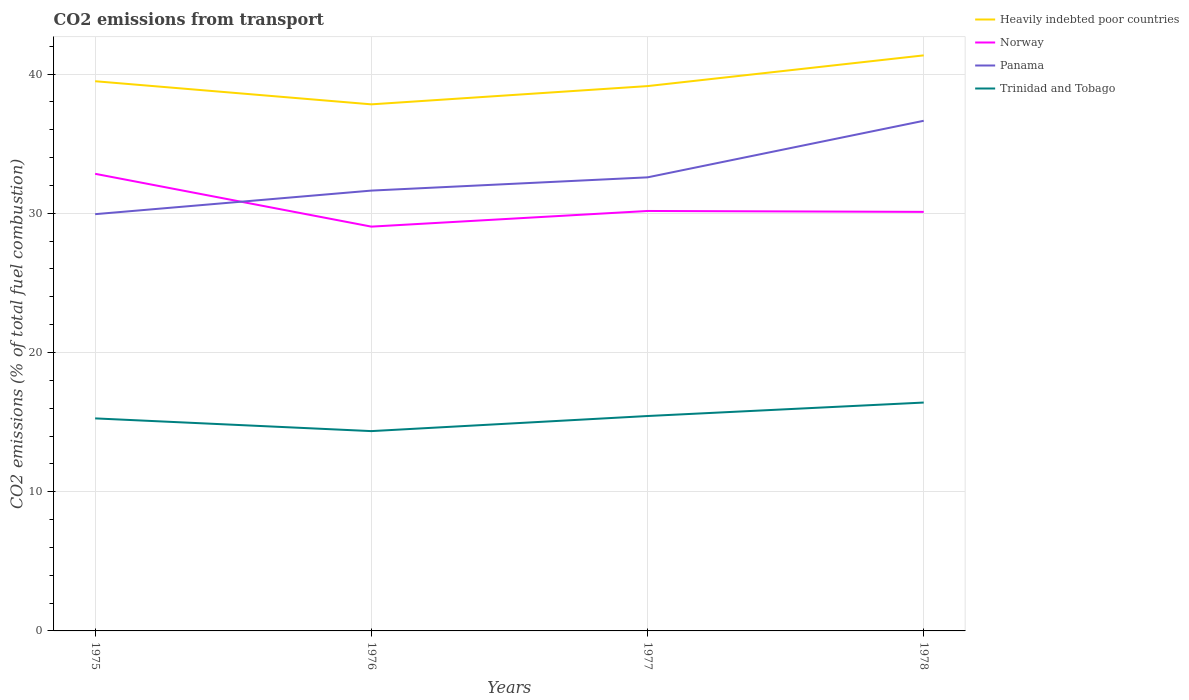Does the line corresponding to Heavily indebted poor countries intersect with the line corresponding to Norway?
Make the answer very short. No. Is the number of lines equal to the number of legend labels?
Your answer should be compact. Yes. Across all years, what is the maximum total CO2 emitted in Heavily indebted poor countries?
Provide a short and direct response. 37.82. In which year was the total CO2 emitted in Trinidad and Tobago maximum?
Offer a very short reply. 1976. What is the total total CO2 emitted in Norway in the graph?
Provide a succinct answer. -1.06. What is the difference between the highest and the second highest total CO2 emitted in Heavily indebted poor countries?
Your response must be concise. 3.52. What is the difference between the highest and the lowest total CO2 emitted in Heavily indebted poor countries?
Make the answer very short. 2. How many years are there in the graph?
Ensure brevity in your answer.  4. Does the graph contain grids?
Your response must be concise. Yes. How many legend labels are there?
Offer a terse response. 4. How are the legend labels stacked?
Make the answer very short. Vertical. What is the title of the graph?
Provide a succinct answer. CO2 emissions from transport. Does "Zambia" appear as one of the legend labels in the graph?
Your answer should be compact. No. What is the label or title of the X-axis?
Offer a terse response. Years. What is the label or title of the Y-axis?
Your answer should be very brief. CO2 emissions (% of total fuel combustion). What is the CO2 emissions (% of total fuel combustion) of Heavily indebted poor countries in 1975?
Your answer should be very brief. 39.49. What is the CO2 emissions (% of total fuel combustion) of Norway in 1975?
Your answer should be compact. 32.84. What is the CO2 emissions (% of total fuel combustion) in Panama in 1975?
Your response must be concise. 29.94. What is the CO2 emissions (% of total fuel combustion) of Trinidad and Tobago in 1975?
Your answer should be compact. 15.27. What is the CO2 emissions (% of total fuel combustion) in Heavily indebted poor countries in 1976?
Offer a terse response. 37.82. What is the CO2 emissions (% of total fuel combustion) in Norway in 1976?
Make the answer very short. 29.04. What is the CO2 emissions (% of total fuel combustion) in Panama in 1976?
Provide a succinct answer. 31.63. What is the CO2 emissions (% of total fuel combustion) in Trinidad and Tobago in 1976?
Offer a terse response. 14.35. What is the CO2 emissions (% of total fuel combustion) in Heavily indebted poor countries in 1977?
Keep it short and to the point. 39.14. What is the CO2 emissions (% of total fuel combustion) in Norway in 1977?
Keep it short and to the point. 30.17. What is the CO2 emissions (% of total fuel combustion) in Panama in 1977?
Give a very brief answer. 32.58. What is the CO2 emissions (% of total fuel combustion) in Trinidad and Tobago in 1977?
Offer a terse response. 15.44. What is the CO2 emissions (% of total fuel combustion) in Heavily indebted poor countries in 1978?
Make the answer very short. 41.34. What is the CO2 emissions (% of total fuel combustion) in Norway in 1978?
Make the answer very short. 30.1. What is the CO2 emissions (% of total fuel combustion) of Panama in 1978?
Offer a terse response. 36.64. What is the CO2 emissions (% of total fuel combustion) in Trinidad and Tobago in 1978?
Make the answer very short. 16.4. Across all years, what is the maximum CO2 emissions (% of total fuel combustion) of Heavily indebted poor countries?
Give a very brief answer. 41.34. Across all years, what is the maximum CO2 emissions (% of total fuel combustion) in Norway?
Provide a succinct answer. 32.84. Across all years, what is the maximum CO2 emissions (% of total fuel combustion) in Panama?
Offer a terse response. 36.64. Across all years, what is the maximum CO2 emissions (% of total fuel combustion) of Trinidad and Tobago?
Offer a terse response. 16.4. Across all years, what is the minimum CO2 emissions (% of total fuel combustion) of Heavily indebted poor countries?
Your answer should be very brief. 37.82. Across all years, what is the minimum CO2 emissions (% of total fuel combustion) of Norway?
Give a very brief answer. 29.04. Across all years, what is the minimum CO2 emissions (% of total fuel combustion) in Panama?
Give a very brief answer. 29.94. Across all years, what is the minimum CO2 emissions (% of total fuel combustion) in Trinidad and Tobago?
Your response must be concise. 14.35. What is the total CO2 emissions (% of total fuel combustion) in Heavily indebted poor countries in the graph?
Provide a succinct answer. 157.79. What is the total CO2 emissions (% of total fuel combustion) of Norway in the graph?
Give a very brief answer. 122.14. What is the total CO2 emissions (% of total fuel combustion) in Panama in the graph?
Provide a succinct answer. 130.79. What is the total CO2 emissions (% of total fuel combustion) in Trinidad and Tobago in the graph?
Offer a very short reply. 61.46. What is the difference between the CO2 emissions (% of total fuel combustion) of Heavily indebted poor countries in 1975 and that in 1976?
Your answer should be very brief. 1.66. What is the difference between the CO2 emissions (% of total fuel combustion) in Norway in 1975 and that in 1976?
Make the answer very short. 3.79. What is the difference between the CO2 emissions (% of total fuel combustion) in Panama in 1975 and that in 1976?
Offer a terse response. -1.69. What is the difference between the CO2 emissions (% of total fuel combustion) of Trinidad and Tobago in 1975 and that in 1976?
Your response must be concise. 0.91. What is the difference between the CO2 emissions (% of total fuel combustion) in Heavily indebted poor countries in 1975 and that in 1977?
Your response must be concise. 0.35. What is the difference between the CO2 emissions (% of total fuel combustion) of Norway in 1975 and that in 1977?
Offer a terse response. 2.67. What is the difference between the CO2 emissions (% of total fuel combustion) of Panama in 1975 and that in 1977?
Give a very brief answer. -2.64. What is the difference between the CO2 emissions (% of total fuel combustion) in Trinidad and Tobago in 1975 and that in 1977?
Your response must be concise. -0.17. What is the difference between the CO2 emissions (% of total fuel combustion) in Heavily indebted poor countries in 1975 and that in 1978?
Provide a succinct answer. -1.86. What is the difference between the CO2 emissions (% of total fuel combustion) of Norway in 1975 and that in 1978?
Offer a very short reply. 2.73. What is the difference between the CO2 emissions (% of total fuel combustion) of Panama in 1975 and that in 1978?
Offer a terse response. -6.71. What is the difference between the CO2 emissions (% of total fuel combustion) of Trinidad and Tobago in 1975 and that in 1978?
Ensure brevity in your answer.  -1.14. What is the difference between the CO2 emissions (% of total fuel combustion) of Heavily indebted poor countries in 1976 and that in 1977?
Offer a terse response. -1.31. What is the difference between the CO2 emissions (% of total fuel combustion) of Norway in 1976 and that in 1977?
Offer a very short reply. -1.12. What is the difference between the CO2 emissions (% of total fuel combustion) in Panama in 1976 and that in 1977?
Ensure brevity in your answer.  -0.95. What is the difference between the CO2 emissions (% of total fuel combustion) in Trinidad and Tobago in 1976 and that in 1977?
Give a very brief answer. -1.08. What is the difference between the CO2 emissions (% of total fuel combustion) in Heavily indebted poor countries in 1976 and that in 1978?
Your answer should be compact. -3.52. What is the difference between the CO2 emissions (% of total fuel combustion) of Norway in 1976 and that in 1978?
Your answer should be very brief. -1.06. What is the difference between the CO2 emissions (% of total fuel combustion) of Panama in 1976 and that in 1978?
Ensure brevity in your answer.  -5.01. What is the difference between the CO2 emissions (% of total fuel combustion) of Trinidad and Tobago in 1976 and that in 1978?
Give a very brief answer. -2.05. What is the difference between the CO2 emissions (% of total fuel combustion) in Heavily indebted poor countries in 1977 and that in 1978?
Provide a succinct answer. -2.21. What is the difference between the CO2 emissions (% of total fuel combustion) in Norway in 1977 and that in 1978?
Provide a succinct answer. 0.07. What is the difference between the CO2 emissions (% of total fuel combustion) of Panama in 1977 and that in 1978?
Your answer should be compact. -4.06. What is the difference between the CO2 emissions (% of total fuel combustion) of Trinidad and Tobago in 1977 and that in 1978?
Offer a terse response. -0.97. What is the difference between the CO2 emissions (% of total fuel combustion) of Heavily indebted poor countries in 1975 and the CO2 emissions (% of total fuel combustion) of Norway in 1976?
Offer a very short reply. 10.44. What is the difference between the CO2 emissions (% of total fuel combustion) in Heavily indebted poor countries in 1975 and the CO2 emissions (% of total fuel combustion) in Panama in 1976?
Provide a succinct answer. 7.86. What is the difference between the CO2 emissions (% of total fuel combustion) of Heavily indebted poor countries in 1975 and the CO2 emissions (% of total fuel combustion) of Trinidad and Tobago in 1976?
Your answer should be very brief. 25.13. What is the difference between the CO2 emissions (% of total fuel combustion) in Norway in 1975 and the CO2 emissions (% of total fuel combustion) in Panama in 1976?
Keep it short and to the point. 1.21. What is the difference between the CO2 emissions (% of total fuel combustion) of Norway in 1975 and the CO2 emissions (% of total fuel combustion) of Trinidad and Tobago in 1976?
Give a very brief answer. 18.48. What is the difference between the CO2 emissions (% of total fuel combustion) of Panama in 1975 and the CO2 emissions (% of total fuel combustion) of Trinidad and Tobago in 1976?
Make the answer very short. 15.58. What is the difference between the CO2 emissions (% of total fuel combustion) in Heavily indebted poor countries in 1975 and the CO2 emissions (% of total fuel combustion) in Norway in 1977?
Your answer should be very brief. 9.32. What is the difference between the CO2 emissions (% of total fuel combustion) of Heavily indebted poor countries in 1975 and the CO2 emissions (% of total fuel combustion) of Panama in 1977?
Ensure brevity in your answer.  6.9. What is the difference between the CO2 emissions (% of total fuel combustion) in Heavily indebted poor countries in 1975 and the CO2 emissions (% of total fuel combustion) in Trinidad and Tobago in 1977?
Make the answer very short. 24.05. What is the difference between the CO2 emissions (% of total fuel combustion) of Norway in 1975 and the CO2 emissions (% of total fuel combustion) of Panama in 1977?
Ensure brevity in your answer.  0.25. What is the difference between the CO2 emissions (% of total fuel combustion) of Norway in 1975 and the CO2 emissions (% of total fuel combustion) of Trinidad and Tobago in 1977?
Ensure brevity in your answer.  17.4. What is the difference between the CO2 emissions (% of total fuel combustion) in Panama in 1975 and the CO2 emissions (% of total fuel combustion) in Trinidad and Tobago in 1977?
Make the answer very short. 14.5. What is the difference between the CO2 emissions (% of total fuel combustion) of Heavily indebted poor countries in 1975 and the CO2 emissions (% of total fuel combustion) of Norway in 1978?
Ensure brevity in your answer.  9.38. What is the difference between the CO2 emissions (% of total fuel combustion) of Heavily indebted poor countries in 1975 and the CO2 emissions (% of total fuel combustion) of Panama in 1978?
Provide a succinct answer. 2.84. What is the difference between the CO2 emissions (% of total fuel combustion) of Heavily indebted poor countries in 1975 and the CO2 emissions (% of total fuel combustion) of Trinidad and Tobago in 1978?
Make the answer very short. 23.08. What is the difference between the CO2 emissions (% of total fuel combustion) in Norway in 1975 and the CO2 emissions (% of total fuel combustion) in Panama in 1978?
Provide a succinct answer. -3.81. What is the difference between the CO2 emissions (% of total fuel combustion) in Norway in 1975 and the CO2 emissions (% of total fuel combustion) in Trinidad and Tobago in 1978?
Provide a short and direct response. 16.43. What is the difference between the CO2 emissions (% of total fuel combustion) in Panama in 1975 and the CO2 emissions (% of total fuel combustion) in Trinidad and Tobago in 1978?
Make the answer very short. 13.53. What is the difference between the CO2 emissions (% of total fuel combustion) of Heavily indebted poor countries in 1976 and the CO2 emissions (% of total fuel combustion) of Norway in 1977?
Ensure brevity in your answer.  7.66. What is the difference between the CO2 emissions (% of total fuel combustion) in Heavily indebted poor countries in 1976 and the CO2 emissions (% of total fuel combustion) in Panama in 1977?
Ensure brevity in your answer.  5.24. What is the difference between the CO2 emissions (% of total fuel combustion) of Heavily indebted poor countries in 1976 and the CO2 emissions (% of total fuel combustion) of Trinidad and Tobago in 1977?
Your response must be concise. 22.39. What is the difference between the CO2 emissions (% of total fuel combustion) in Norway in 1976 and the CO2 emissions (% of total fuel combustion) in Panama in 1977?
Provide a short and direct response. -3.54. What is the difference between the CO2 emissions (% of total fuel combustion) in Norway in 1976 and the CO2 emissions (% of total fuel combustion) in Trinidad and Tobago in 1977?
Ensure brevity in your answer.  13.6. What is the difference between the CO2 emissions (% of total fuel combustion) in Panama in 1976 and the CO2 emissions (% of total fuel combustion) in Trinidad and Tobago in 1977?
Your answer should be very brief. 16.19. What is the difference between the CO2 emissions (% of total fuel combustion) of Heavily indebted poor countries in 1976 and the CO2 emissions (% of total fuel combustion) of Norway in 1978?
Your response must be concise. 7.72. What is the difference between the CO2 emissions (% of total fuel combustion) in Heavily indebted poor countries in 1976 and the CO2 emissions (% of total fuel combustion) in Panama in 1978?
Provide a short and direct response. 1.18. What is the difference between the CO2 emissions (% of total fuel combustion) in Heavily indebted poor countries in 1976 and the CO2 emissions (% of total fuel combustion) in Trinidad and Tobago in 1978?
Give a very brief answer. 21.42. What is the difference between the CO2 emissions (% of total fuel combustion) in Norway in 1976 and the CO2 emissions (% of total fuel combustion) in Panama in 1978?
Your answer should be very brief. -7.6. What is the difference between the CO2 emissions (% of total fuel combustion) in Norway in 1976 and the CO2 emissions (% of total fuel combustion) in Trinidad and Tobago in 1978?
Make the answer very short. 12.64. What is the difference between the CO2 emissions (% of total fuel combustion) of Panama in 1976 and the CO2 emissions (% of total fuel combustion) of Trinidad and Tobago in 1978?
Your response must be concise. 15.23. What is the difference between the CO2 emissions (% of total fuel combustion) of Heavily indebted poor countries in 1977 and the CO2 emissions (% of total fuel combustion) of Norway in 1978?
Make the answer very short. 9.04. What is the difference between the CO2 emissions (% of total fuel combustion) in Heavily indebted poor countries in 1977 and the CO2 emissions (% of total fuel combustion) in Panama in 1978?
Ensure brevity in your answer.  2.49. What is the difference between the CO2 emissions (% of total fuel combustion) in Heavily indebted poor countries in 1977 and the CO2 emissions (% of total fuel combustion) in Trinidad and Tobago in 1978?
Your response must be concise. 22.73. What is the difference between the CO2 emissions (% of total fuel combustion) in Norway in 1977 and the CO2 emissions (% of total fuel combustion) in Panama in 1978?
Ensure brevity in your answer.  -6.48. What is the difference between the CO2 emissions (% of total fuel combustion) of Norway in 1977 and the CO2 emissions (% of total fuel combustion) of Trinidad and Tobago in 1978?
Offer a terse response. 13.76. What is the difference between the CO2 emissions (% of total fuel combustion) in Panama in 1977 and the CO2 emissions (% of total fuel combustion) in Trinidad and Tobago in 1978?
Ensure brevity in your answer.  16.18. What is the average CO2 emissions (% of total fuel combustion) of Heavily indebted poor countries per year?
Offer a terse response. 39.45. What is the average CO2 emissions (% of total fuel combustion) of Norway per year?
Your response must be concise. 30.54. What is the average CO2 emissions (% of total fuel combustion) in Panama per year?
Keep it short and to the point. 32.7. What is the average CO2 emissions (% of total fuel combustion) in Trinidad and Tobago per year?
Offer a very short reply. 15.36. In the year 1975, what is the difference between the CO2 emissions (% of total fuel combustion) in Heavily indebted poor countries and CO2 emissions (% of total fuel combustion) in Norway?
Keep it short and to the point. 6.65. In the year 1975, what is the difference between the CO2 emissions (% of total fuel combustion) in Heavily indebted poor countries and CO2 emissions (% of total fuel combustion) in Panama?
Keep it short and to the point. 9.55. In the year 1975, what is the difference between the CO2 emissions (% of total fuel combustion) in Heavily indebted poor countries and CO2 emissions (% of total fuel combustion) in Trinidad and Tobago?
Keep it short and to the point. 24.22. In the year 1975, what is the difference between the CO2 emissions (% of total fuel combustion) of Norway and CO2 emissions (% of total fuel combustion) of Panama?
Your answer should be compact. 2.9. In the year 1975, what is the difference between the CO2 emissions (% of total fuel combustion) of Norway and CO2 emissions (% of total fuel combustion) of Trinidad and Tobago?
Keep it short and to the point. 17.57. In the year 1975, what is the difference between the CO2 emissions (% of total fuel combustion) in Panama and CO2 emissions (% of total fuel combustion) in Trinidad and Tobago?
Keep it short and to the point. 14.67. In the year 1976, what is the difference between the CO2 emissions (% of total fuel combustion) of Heavily indebted poor countries and CO2 emissions (% of total fuel combustion) of Norway?
Provide a short and direct response. 8.78. In the year 1976, what is the difference between the CO2 emissions (% of total fuel combustion) in Heavily indebted poor countries and CO2 emissions (% of total fuel combustion) in Panama?
Ensure brevity in your answer.  6.2. In the year 1976, what is the difference between the CO2 emissions (% of total fuel combustion) of Heavily indebted poor countries and CO2 emissions (% of total fuel combustion) of Trinidad and Tobago?
Your answer should be very brief. 23.47. In the year 1976, what is the difference between the CO2 emissions (% of total fuel combustion) of Norway and CO2 emissions (% of total fuel combustion) of Panama?
Offer a very short reply. -2.59. In the year 1976, what is the difference between the CO2 emissions (% of total fuel combustion) of Norway and CO2 emissions (% of total fuel combustion) of Trinidad and Tobago?
Provide a succinct answer. 14.69. In the year 1976, what is the difference between the CO2 emissions (% of total fuel combustion) of Panama and CO2 emissions (% of total fuel combustion) of Trinidad and Tobago?
Your answer should be compact. 17.28. In the year 1977, what is the difference between the CO2 emissions (% of total fuel combustion) of Heavily indebted poor countries and CO2 emissions (% of total fuel combustion) of Norway?
Your response must be concise. 8.97. In the year 1977, what is the difference between the CO2 emissions (% of total fuel combustion) in Heavily indebted poor countries and CO2 emissions (% of total fuel combustion) in Panama?
Give a very brief answer. 6.55. In the year 1977, what is the difference between the CO2 emissions (% of total fuel combustion) in Heavily indebted poor countries and CO2 emissions (% of total fuel combustion) in Trinidad and Tobago?
Keep it short and to the point. 23.7. In the year 1977, what is the difference between the CO2 emissions (% of total fuel combustion) in Norway and CO2 emissions (% of total fuel combustion) in Panama?
Provide a succinct answer. -2.41. In the year 1977, what is the difference between the CO2 emissions (% of total fuel combustion) of Norway and CO2 emissions (% of total fuel combustion) of Trinidad and Tobago?
Offer a very short reply. 14.73. In the year 1977, what is the difference between the CO2 emissions (% of total fuel combustion) in Panama and CO2 emissions (% of total fuel combustion) in Trinidad and Tobago?
Offer a very short reply. 17.14. In the year 1978, what is the difference between the CO2 emissions (% of total fuel combustion) of Heavily indebted poor countries and CO2 emissions (% of total fuel combustion) of Norway?
Ensure brevity in your answer.  11.24. In the year 1978, what is the difference between the CO2 emissions (% of total fuel combustion) in Heavily indebted poor countries and CO2 emissions (% of total fuel combustion) in Panama?
Your answer should be very brief. 4.7. In the year 1978, what is the difference between the CO2 emissions (% of total fuel combustion) in Heavily indebted poor countries and CO2 emissions (% of total fuel combustion) in Trinidad and Tobago?
Offer a very short reply. 24.94. In the year 1978, what is the difference between the CO2 emissions (% of total fuel combustion) in Norway and CO2 emissions (% of total fuel combustion) in Panama?
Give a very brief answer. -6.54. In the year 1978, what is the difference between the CO2 emissions (% of total fuel combustion) in Norway and CO2 emissions (% of total fuel combustion) in Trinidad and Tobago?
Your answer should be compact. 13.7. In the year 1978, what is the difference between the CO2 emissions (% of total fuel combustion) in Panama and CO2 emissions (% of total fuel combustion) in Trinidad and Tobago?
Keep it short and to the point. 20.24. What is the ratio of the CO2 emissions (% of total fuel combustion) in Heavily indebted poor countries in 1975 to that in 1976?
Your answer should be compact. 1.04. What is the ratio of the CO2 emissions (% of total fuel combustion) of Norway in 1975 to that in 1976?
Provide a succinct answer. 1.13. What is the ratio of the CO2 emissions (% of total fuel combustion) of Panama in 1975 to that in 1976?
Give a very brief answer. 0.95. What is the ratio of the CO2 emissions (% of total fuel combustion) of Trinidad and Tobago in 1975 to that in 1976?
Your answer should be very brief. 1.06. What is the ratio of the CO2 emissions (% of total fuel combustion) in Heavily indebted poor countries in 1975 to that in 1977?
Ensure brevity in your answer.  1.01. What is the ratio of the CO2 emissions (% of total fuel combustion) in Norway in 1975 to that in 1977?
Provide a short and direct response. 1.09. What is the ratio of the CO2 emissions (% of total fuel combustion) of Panama in 1975 to that in 1977?
Keep it short and to the point. 0.92. What is the ratio of the CO2 emissions (% of total fuel combustion) of Trinidad and Tobago in 1975 to that in 1977?
Offer a very short reply. 0.99. What is the ratio of the CO2 emissions (% of total fuel combustion) of Heavily indebted poor countries in 1975 to that in 1978?
Give a very brief answer. 0.96. What is the ratio of the CO2 emissions (% of total fuel combustion) of Norway in 1975 to that in 1978?
Give a very brief answer. 1.09. What is the ratio of the CO2 emissions (% of total fuel combustion) of Panama in 1975 to that in 1978?
Offer a very short reply. 0.82. What is the ratio of the CO2 emissions (% of total fuel combustion) in Trinidad and Tobago in 1975 to that in 1978?
Offer a terse response. 0.93. What is the ratio of the CO2 emissions (% of total fuel combustion) in Heavily indebted poor countries in 1976 to that in 1977?
Your response must be concise. 0.97. What is the ratio of the CO2 emissions (% of total fuel combustion) in Norway in 1976 to that in 1977?
Ensure brevity in your answer.  0.96. What is the ratio of the CO2 emissions (% of total fuel combustion) of Panama in 1976 to that in 1977?
Make the answer very short. 0.97. What is the ratio of the CO2 emissions (% of total fuel combustion) of Trinidad and Tobago in 1976 to that in 1977?
Make the answer very short. 0.93. What is the ratio of the CO2 emissions (% of total fuel combustion) in Heavily indebted poor countries in 1976 to that in 1978?
Offer a terse response. 0.91. What is the ratio of the CO2 emissions (% of total fuel combustion) of Norway in 1976 to that in 1978?
Keep it short and to the point. 0.96. What is the ratio of the CO2 emissions (% of total fuel combustion) of Panama in 1976 to that in 1978?
Ensure brevity in your answer.  0.86. What is the ratio of the CO2 emissions (% of total fuel combustion) in Trinidad and Tobago in 1976 to that in 1978?
Keep it short and to the point. 0.87. What is the ratio of the CO2 emissions (% of total fuel combustion) in Heavily indebted poor countries in 1977 to that in 1978?
Your answer should be very brief. 0.95. What is the ratio of the CO2 emissions (% of total fuel combustion) in Panama in 1977 to that in 1978?
Provide a succinct answer. 0.89. What is the ratio of the CO2 emissions (% of total fuel combustion) of Trinidad and Tobago in 1977 to that in 1978?
Offer a very short reply. 0.94. What is the difference between the highest and the second highest CO2 emissions (% of total fuel combustion) of Heavily indebted poor countries?
Your answer should be compact. 1.86. What is the difference between the highest and the second highest CO2 emissions (% of total fuel combustion) in Norway?
Make the answer very short. 2.67. What is the difference between the highest and the second highest CO2 emissions (% of total fuel combustion) of Panama?
Your response must be concise. 4.06. What is the difference between the highest and the lowest CO2 emissions (% of total fuel combustion) of Heavily indebted poor countries?
Provide a short and direct response. 3.52. What is the difference between the highest and the lowest CO2 emissions (% of total fuel combustion) in Norway?
Provide a succinct answer. 3.79. What is the difference between the highest and the lowest CO2 emissions (% of total fuel combustion) of Panama?
Ensure brevity in your answer.  6.71. What is the difference between the highest and the lowest CO2 emissions (% of total fuel combustion) of Trinidad and Tobago?
Offer a very short reply. 2.05. 